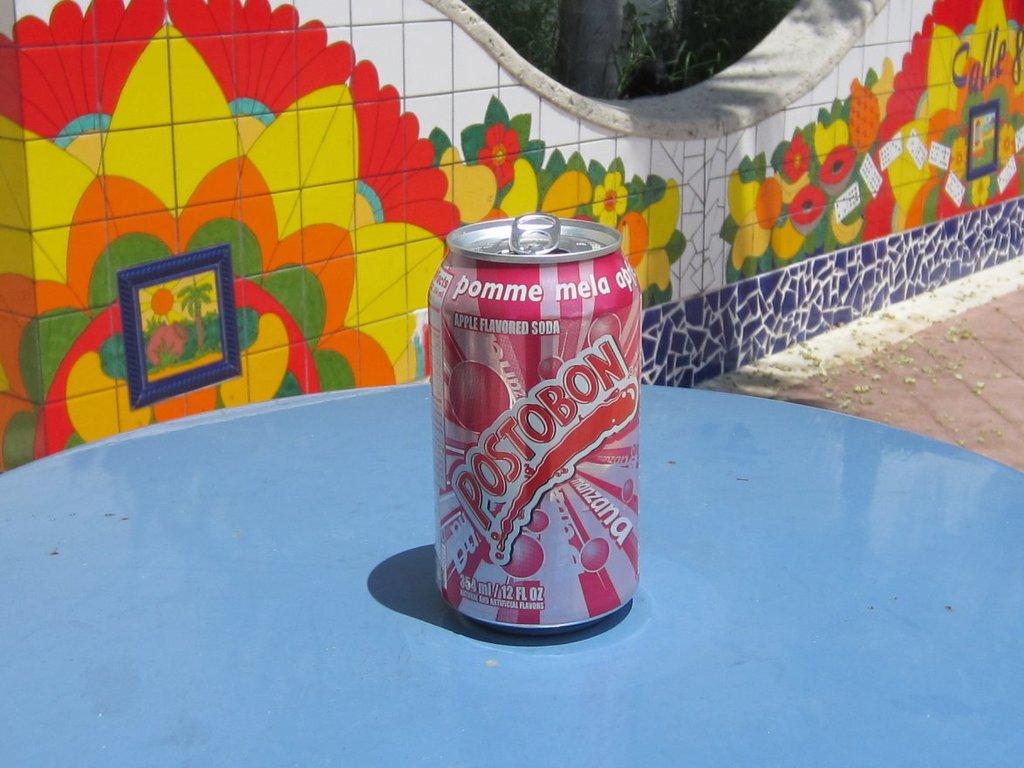How many ounces in this can?
Your answer should be very brief. 12. 